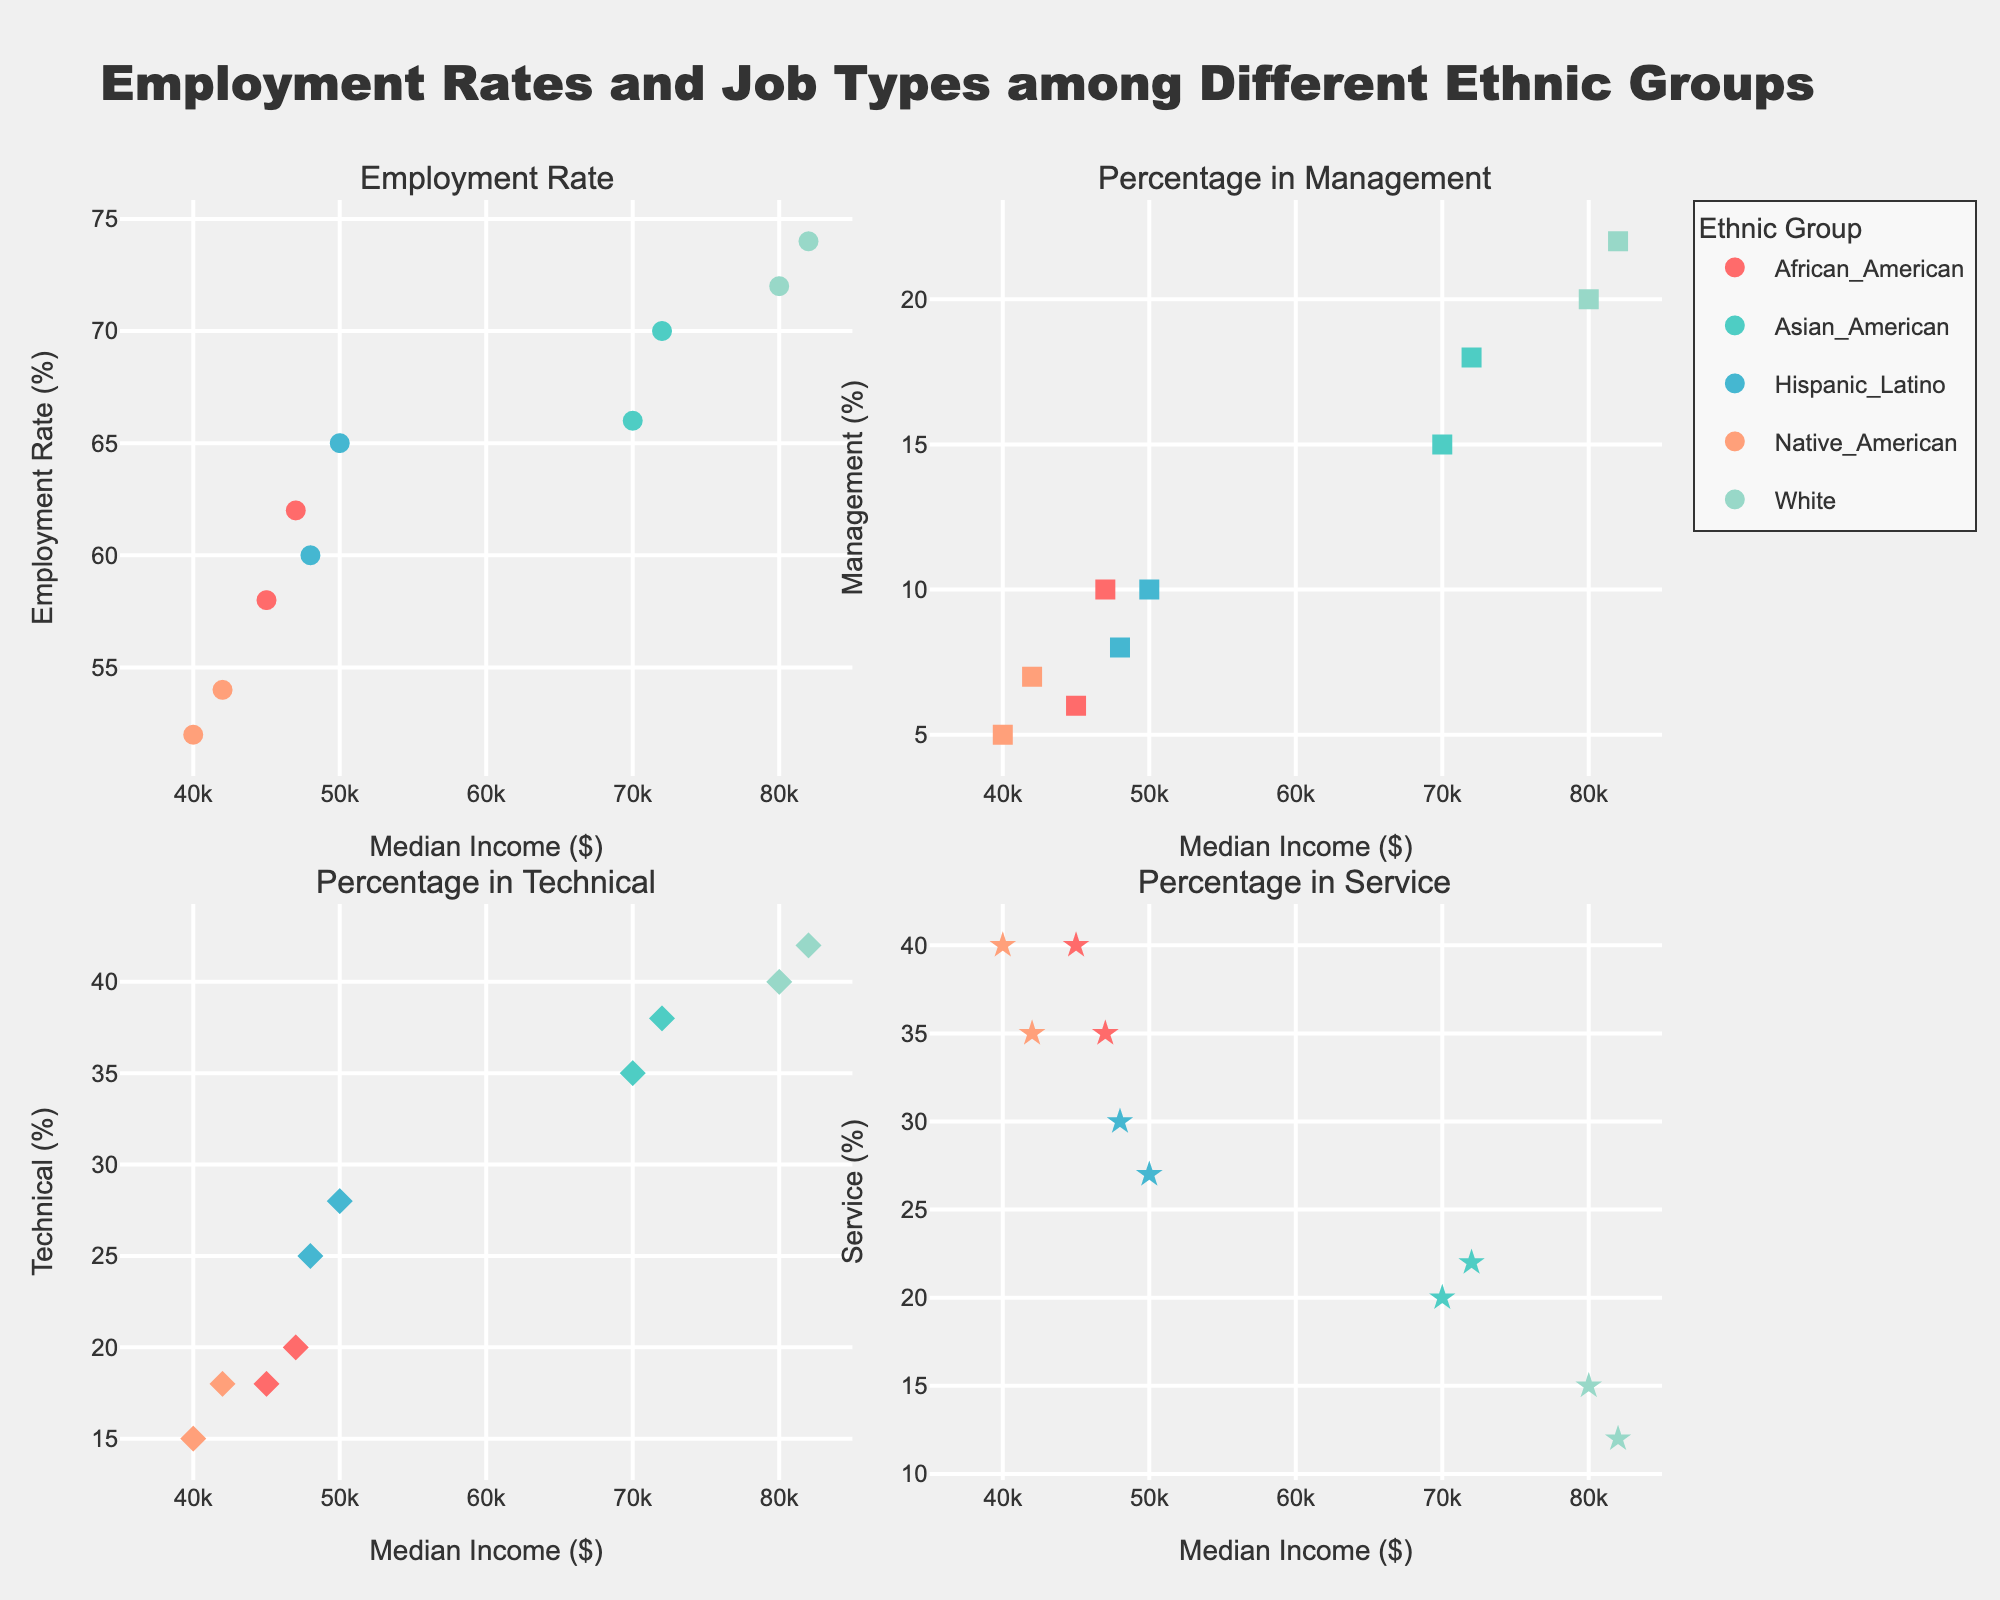What is the title of the figure? The title of the figure is clearly written on top and reads "Employment Rates and Job Types among Different Ethnic Groups".
Answer: Employment Rates and Job Types among Different Ethnic Groups What information is represented on the x-axis of the plots? The x-axis of all the subplots represents Median Income in dollars, with values ranging from $35,000 to $85,000.
Answer: Median Income How many ethnic groups are represented in the figure? By looking at the color-coded legend, we can see that there are five ethnic groups represented: African American, Asian American, Hispanic/Latino, Native American, and White.
Answer: Five Which ethnic group has the highest employment rate? In the subplot titled "Employment Rate", we can see that the highest employment rate is 74%, represented by White.
Answer: White Which ethnic group has the lowest percentage in management positions? In the subplot titled "Percentage in Management", Native American has the lowest percentage, represented by the point located at ~5%.
Answer: Native American What is the employment rate of Hispanic/Latino when the median income is $50,000? From the first subplot "Employment Rate", the point for Hispanic/Latino when the median income is $50,000 shows an employment rate of 65%.
Answer: 65% In the technical job category, which ethnic group has the lowest representation? In the subplot titled "Percentage in Technical", Native American has the lowest representation, represented by a point around the 15% mark.
Answer: Native American Compare the median incomes of African American and White groups. Which is higher, and by how much? The points in each subplot show that the median income of the White group is $82,000, while that of African American is $47,000. The difference is $82,000 - $47,000 = $35,000.
Answer: White by $35,000 Is there any ethnic group that appears identical in the "Percentage in Service" and "Employment Rate" subplots? If yes, which one? By examining the scatter points in both the "Percentage in Service" and "Employment Rate" subplots, Native American points at ~52% employment rate and ~52% service jobs.
Answer: Native American For the Hispanic/Latino group, how does the percentage in technical jobs compare between the two years? Two markers in the "Percentage in Technical" subplot represent Hispanic/Latino with median incomes around $48,000 and $50,000 showing percentages of 25% and 28%, respectively. This indicates a 3% increase in the percentage of technical jobs.
Answer: 3% increase 